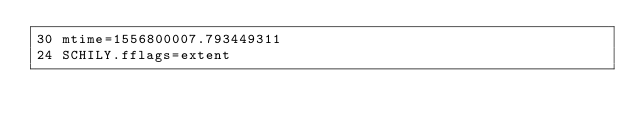Convert code to text. <code><loc_0><loc_0><loc_500><loc_500><_CSS_>30 mtime=1556800007.793449311
24 SCHILY.fflags=extent
</code> 